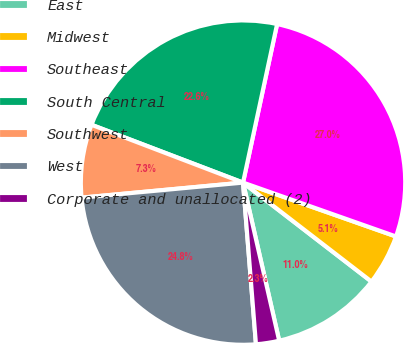Convert chart to OTSL. <chart><loc_0><loc_0><loc_500><loc_500><pie_chart><fcel>East<fcel>Midwest<fcel>Southeast<fcel>South Central<fcel>Southwest<fcel>West<fcel>Corporate and unallocated (2)<nl><fcel>10.97%<fcel>5.06%<fcel>27.02%<fcel>22.57%<fcel>7.28%<fcel>24.79%<fcel>2.31%<nl></chart> 